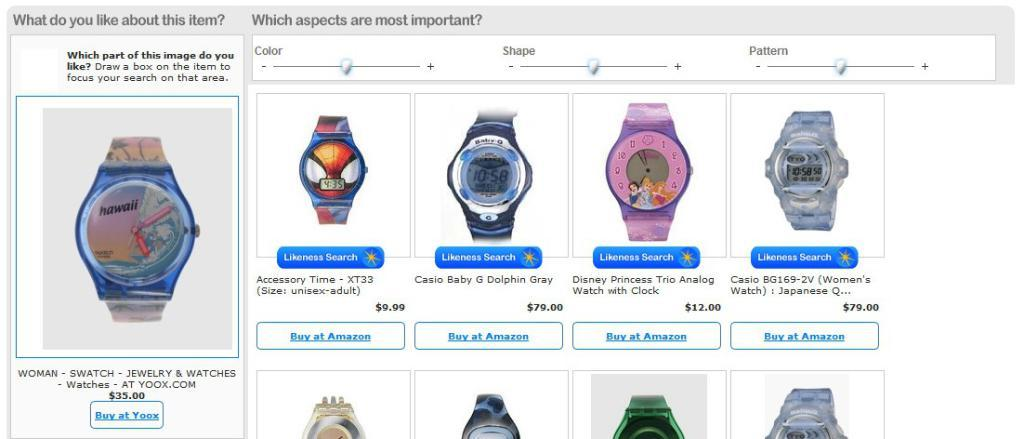<image>
Describe the image concisely. A set of watches are on display and a button is beneath them that says Buy at Amazon. 